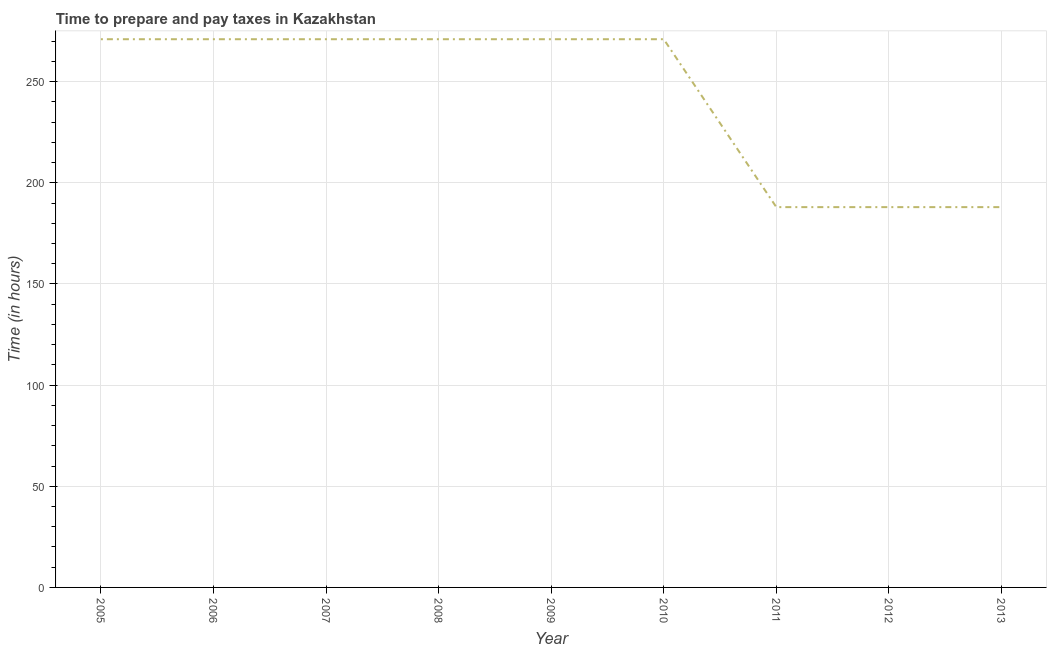What is the time to prepare and pay taxes in 2010?
Offer a terse response. 271. Across all years, what is the maximum time to prepare and pay taxes?
Ensure brevity in your answer.  271. Across all years, what is the minimum time to prepare and pay taxes?
Make the answer very short. 188. What is the sum of the time to prepare and pay taxes?
Your answer should be compact. 2190. What is the average time to prepare and pay taxes per year?
Your answer should be very brief. 243.33. What is the median time to prepare and pay taxes?
Provide a succinct answer. 271. In how many years, is the time to prepare and pay taxes greater than 30 hours?
Give a very brief answer. 9. Do a majority of the years between 2007 and 2008 (inclusive) have time to prepare and pay taxes greater than 90 hours?
Ensure brevity in your answer.  Yes. What is the ratio of the time to prepare and pay taxes in 2012 to that in 2013?
Your answer should be very brief. 1. Is the time to prepare and pay taxes in 2010 less than that in 2011?
Provide a short and direct response. No. Is the difference between the time to prepare and pay taxes in 2005 and 2011 greater than the difference between any two years?
Your answer should be very brief. Yes. What is the difference between the highest and the lowest time to prepare and pay taxes?
Ensure brevity in your answer.  83. What is the difference between two consecutive major ticks on the Y-axis?
Your answer should be compact. 50. Are the values on the major ticks of Y-axis written in scientific E-notation?
Your response must be concise. No. Does the graph contain any zero values?
Offer a terse response. No. What is the title of the graph?
Your answer should be very brief. Time to prepare and pay taxes in Kazakhstan. What is the label or title of the X-axis?
Offer a terse response. Year. What is the label or title of the Y-axis?
Give a very brief answer. Time (in hours). What is the Time (in hours) of 2005?
Your response must be concise. 271. What is the Time (in hours) of 2006?
Ensure brevity in your answer.  271. What is the Time (in hours) in 2007?
Make the answer very short. 271. What is the Time (in hours) of 2008?
Provide a short and direct response. 271. What is the Time (in hours) of 2009?
Your answer should be very brief. 271. What is the Time (in hours) in 2010?
Provide a succinct answer. 271. What is the Time (in hours) of 2011?
Offer a very short reply. 188. What is the Time (in hours) of 2012?
Your response must be concise. 188. What is the Time (in hours) of 2013?
Provide a short and direct response. 188. What is the difference between the Time (in hours) in 2005 and 2007?
Make the answer very short. 0. What is the difference between the Time (in hours) in 2005 and 2008?
Your answer should be very brief. 0. What is the difference between the Time (in hours) in 2005 and 2009?
Give a very brief answer. 0. What is the difference between the Time (in hours) in 2005 and 2010?
Provide a succinct answer. 0. What is the difference between the Time (in hours) in 2005 and 2011?
Offer a terse response. 83. What is the difference between the Time (in hours) in 2005 and 2012?
Your answer should be compact. 83. What is the difference between the Time (in hours) in 2006 and 2008?
Your response must be concise. 0. What is the difference between the Time (in hours) in 2006 and 2009?
Offer a terse response. 0. What is the difference between the Time (in hours) in 2006 and 2010?
Give a very brief answer. 0. What is the difference between the Time (in hours) in 2007 and 2009?
Your response must be concise. 0. What is the difference between the Time (in hours) in 2007 and 2010?
Offer a terse response. 0. What is the difference between the Time (in hours) in 2007 and 2011?
Provide a succinct answer. 83. What is the difference between the Time (in hours) in 2007 and 2012?
Offer a very short reply. 83. What is the difference between the Time (in hours) in 2008 and 2009?
Give a very brief answer. 0. What is the difference between the Time (in hours) in 2008 and 2011?
Provide a short and direct response. 83. What is the difference between the Time (in hours) in 2008 and 2012?
Provide a succinct answer. 83. What is the difference between the Time (in hours) in 2008 and 2013?
Offer a very short reply. 83. What is the difference between the Time (in hours) in 2009 and 2010?
Offer a very short reply. 0. What is the difference between the Time (in hours) in 2009 and 2011?
Offer a terse response. 83. What is the difference between the Time (in hours) in 2009 and 2012?
Provide a succinct answer. 83. What is the difference between the Time (in hours) in 2009 and 2013?
Your answer should be compact. 83. What is the difference between the Time (in hours) in 2010 and 2013?
Make the answer very short. 83. What is the difference between the Time (in hours) in 2011 and 2012?
Offer a very short reply. 0. What is the difference between the Time (in hours) in 2012 and 2013?
Offer a very short reply. 0. What is the ratio of the Time (in hours) in 2005 to that in 2006?
Provide a short and direct response. 1. What is the ratio of the Time (in hours) in 2005 to that in 2007?
Make the answer very short. 1. What is the ratio of the Time (in hours) in 2005 to that in 2008?
Provide a succinct answer. 1. What is the ratio of the Time (in hours) in 2005 to that in 2011?
Make the answer very short. 1.44. What is the ratio of the Time (in hours) in 2005 to that in 2012?
Your response must be concise. 1.44. What is the ratio of the Time (in hours) in 2005 to that in 2013?
Keep it short and to the point. 1.44. What is the ratio of the Time (in hours) in 2006 to that in 2008?
Your answer should be compact. 1. What is the ratio of the Time (in hours) in 2006 to that in 2009?
Make the answer very short. 1. What is the ratio of the Time (in hours) in 2006 to that in 2010?
Offer a terse response. 1. What is the ratio of the Time (in hours) in 2006 to that in 2011?
Offer a very short reply. 1.44. What is the ratio of the Time (in hours) in 2006 to that in 2012?
Make the answer very short. 1.44. What is the ratio of the Time (in hours) in 2006 to that in 2013?
Keep it short and to the point. 1.44. What is the ratio of the Time (in hours) in 2007 to that in 2009?
Give a very brief answer. 1. What is the ratio of the Time (in hours) in 2007 to that in 2011?
Provide a succinct answer. 1.44. What is the ratio of the Time (in hours) in 2007 to that in 2012?
Your response must be concise. 1.44. What is the ratio of the Time (in hours) in 2007 to that in 2013?
Provide a short and direct response. 1.44. What is the ratio of the Time (in hours) in 2008 to that in 2011?
Provide a short and direct response. 1.44. What is the ratio of the Time (in hours) in 2008 to that in 2012?
Provide a short and direct response. 1.44. What is the ratio of the Time (in hours) in 2008 to that in 2013?
Keep it short and to the point. 1.44. What is the ratio of the Time (in hours) in 2009 to that in 2011?
Make the answer very short. 1.44. What is the ratio of the Time (in hours) in 2009 to that in 2012?
Provide a succinct answer. 1.44. What is the ratio of the Time (in hours) in 2009 to that in 2013?
Offer a very short reply. 1.44. What is the ratio of the Time (in hours) in 2010 to that in 2011?
Give a very brief answer. 1.44. What is the ratio of the Time (in hours) in 2010 to that in 2012?
Give a very brief answer. 1.44. What is the ratio of the Time (in hours) in 2010 to that in 2013?
Keep it short and to the point. 1.44. What is the ratio of the Time (in hours) in 2011 to that in 2013?
Offer a terse response. 1. What is the ratio of the Time (in hours) in 2012 to that in 2013?
Provide a short and direct response. 1. 